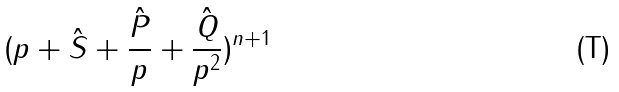<formula> <loc_0><loc_0><loc_500><loc_500>( p + { \hat { S } } + \frac { \hat { P } } { p } + \frac { \hat { Q } } { p ^ { 2 } } ) ^ { n + 1 }</formula> 